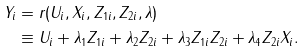<formula> <loc_0><loc_0><loc_500><loc_500>Y _ { i } & = r ( U _ { i } , X _ { i } , Z _ { 1 i } , Z _ { 2 i } , \lambda ) \\ & \equiv U _ { i } + \lambda _ { 1 } Z _ { 1 i } + \lambda _ { 2 } Z _ { 2 i } + \lambda _ { 3 } Z _ { 1 i } Z _ { 2 i } + \lambda _ { 4 } Z _ { 2 i } X _ { i } .</formula> 